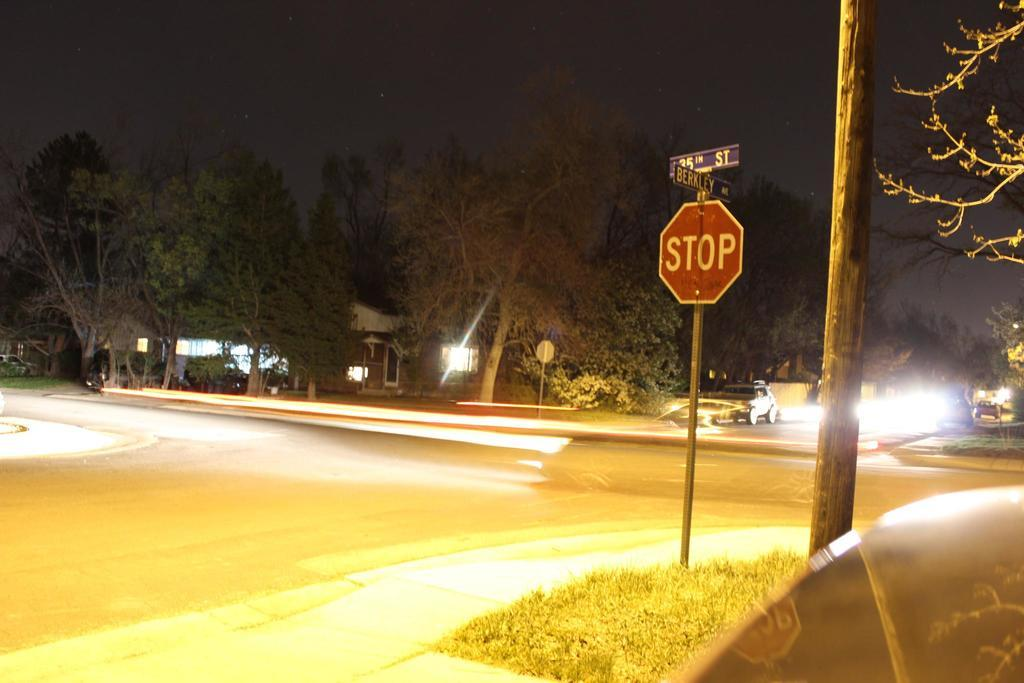<image>
Relay a brief, clear account of the picture shown. The sign shows Berkeley avenue and 35th street. 